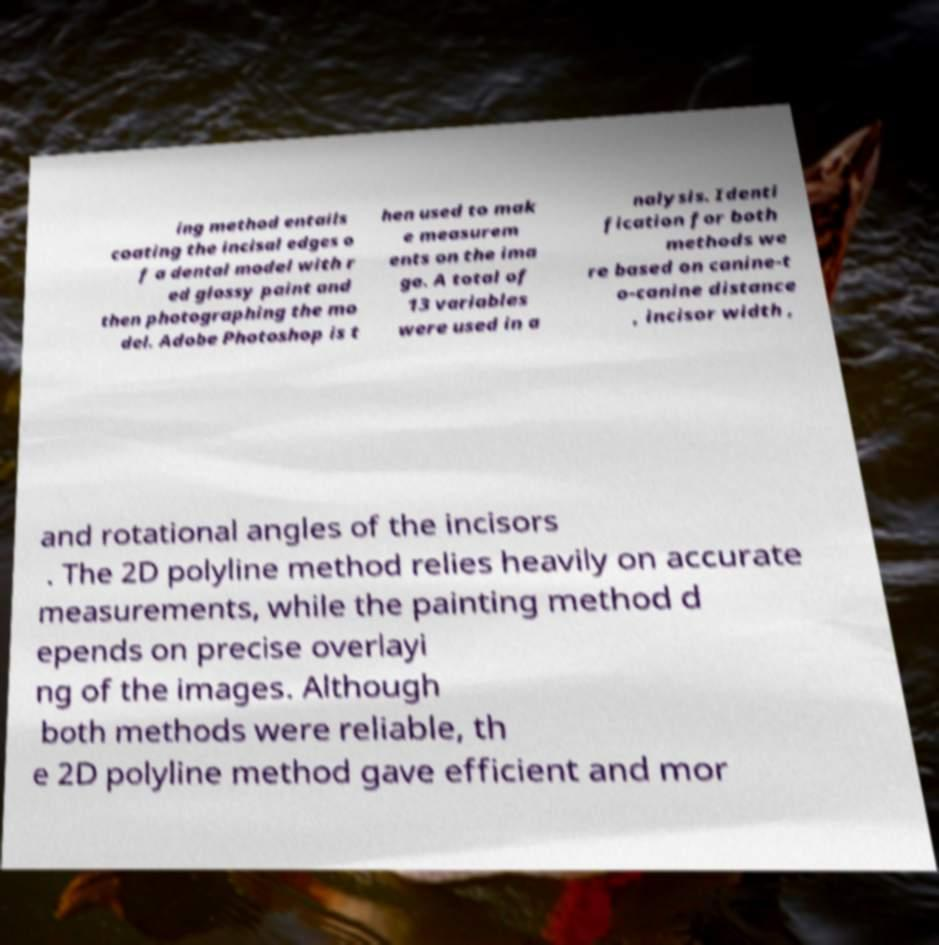Please read and relay the text visible in this image. What does it say? ing method entails coating the incisal edges o f a dental model with r ed glossy paint and then photographing the mo del. Adobe Photoshop is t hen used to mak e measurem ents on the ima ge. A total of 13 variables were used in a nalysis. Identi fication for both methods we re based on canine-t o-canine distance , incisor width , and rotational angles of the incisors . The 2D polyline method relies heavily on accurate measurements, while the painting method d epends on precise overlayi ng of the images. Although both methods were reliable, th e 2D polyline method gave efficient and mor 